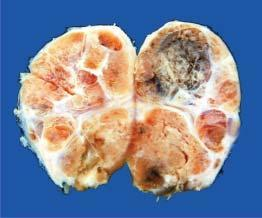re the functional divisions of the lobule into 3 zones also seen?
Answer the question using a single word or phrase. No 